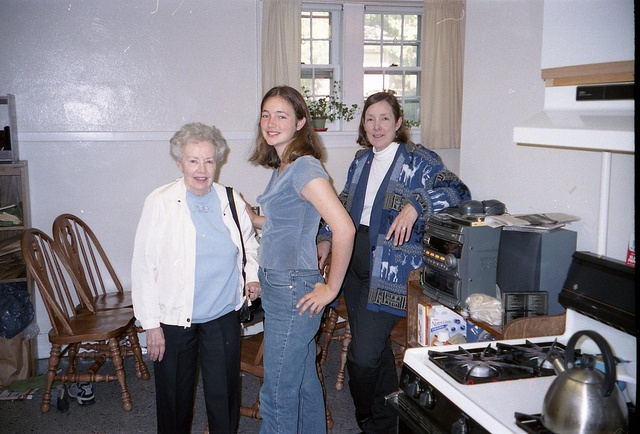Describe the objects in this image and their specific colors. I can see people in gray, lightgray, black, lavender, and darkgray tones, people in gray, darkgray, and lightpink tones, people in gray, black, darkblue, and navy tones, oven in gray, black, lavender, and darkgray tones, and chair in gray, black, maroon, and darkgray tones in this image. 